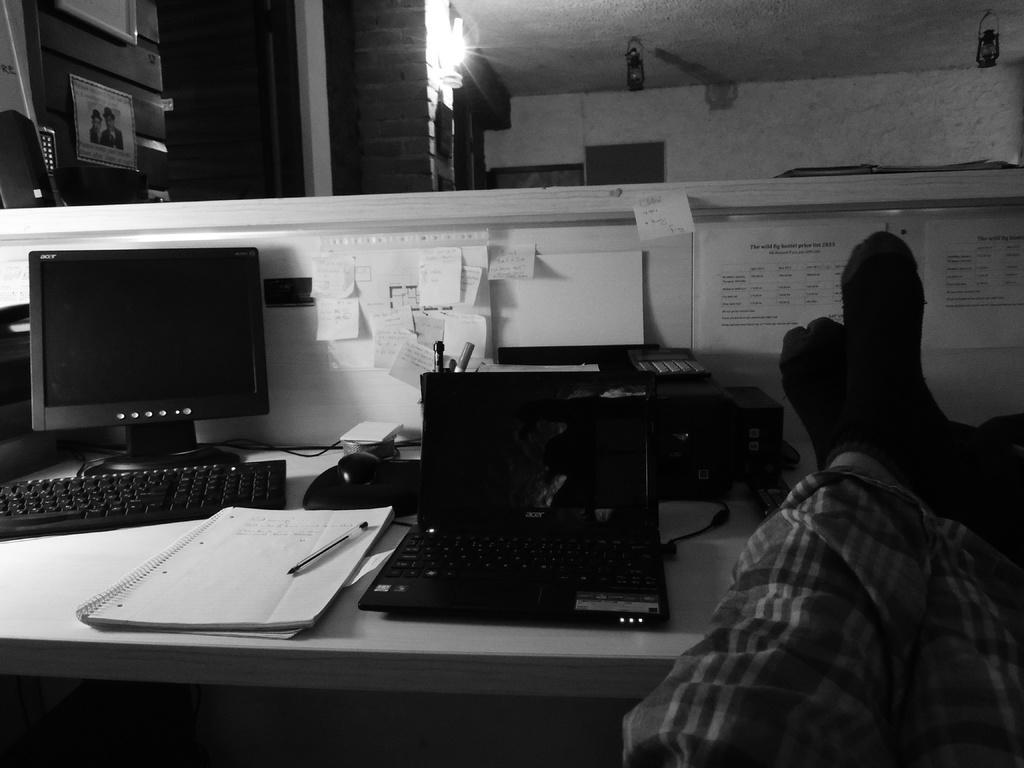In one or two sentences, can you explain what this image depicts? This is a black and white image. In this image we can see persons legs on the table. There is a laptop. There is a book and a pen. To the left side of the image there is a monitor, Keyboard, mouse and other objects on the table. There are papers sticked on the table. In the background of the image there is wall. At the top of the image there is ceiling with lights. 